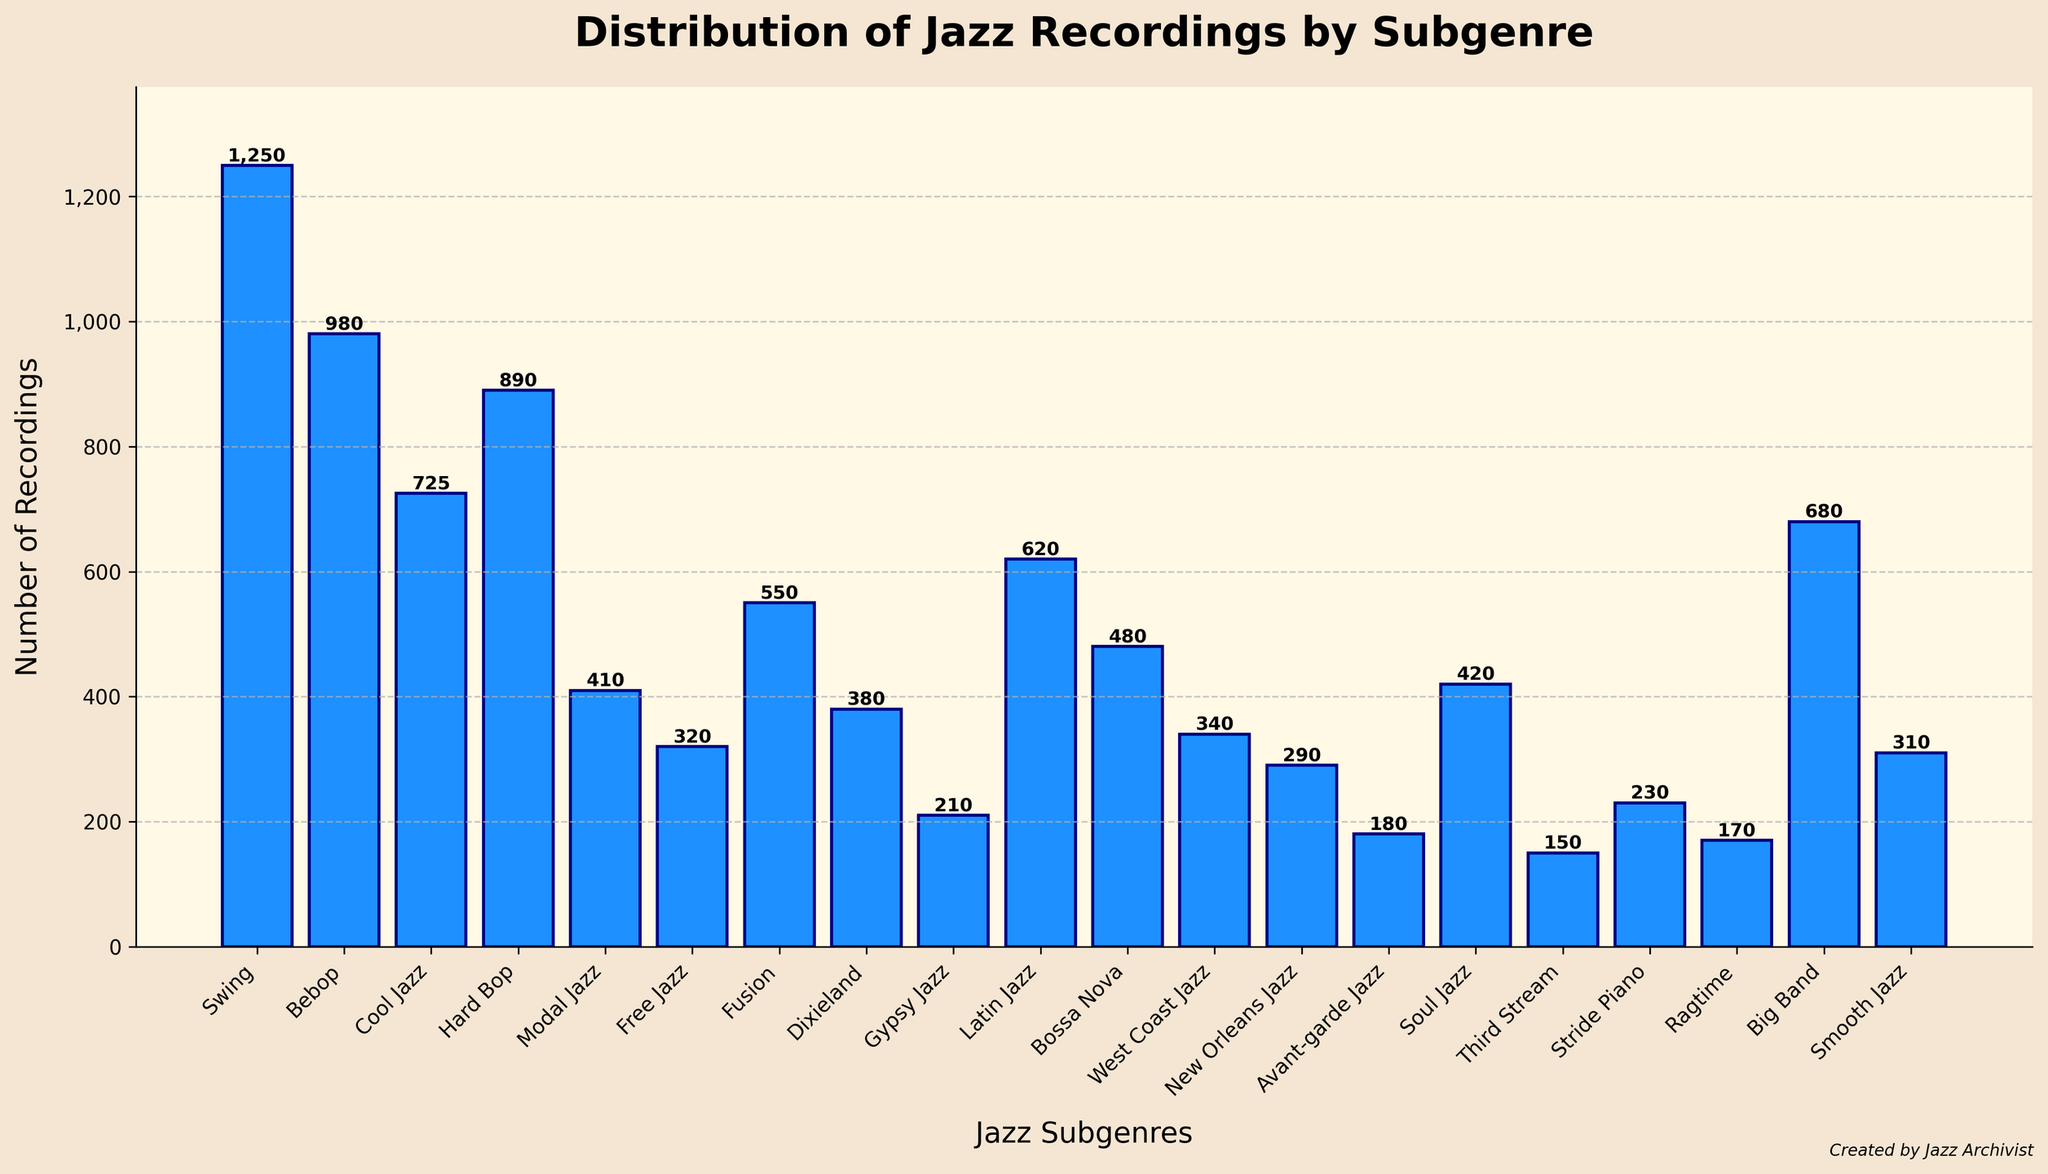What's the most common subgenre of jazz recordings? The figure highlights the frequency of each subgenre by the height of the bars. The tallest bar represents Swing with 1250 recordings, making it the most common subgenre.
Answer: Swing Which subgenre has fewer recordings, Cool Jazz or Bebop? Comparing the bars for Cool Jazz and Bebop shows that Bebop has 980 recordings, which is higher than Cool Jazz's 725 recordings. Thus, Cool Jazz has fewer recordings.
Answer: Cool Jazz What's the combined total of recordings for Free Jazz, Gypsy Jazz, and Ragtime? To find this, add the values of Free Jazz (320), Gypsy Jazz (210), and Ragtime (170). The sum is 320 + 210 + 170 = 700.
Answer: 700 How many more recordings does Swing have compared to Avant-garde Jazz? Subtract the number of recordings for Avant-garde Jazz (180) from Swing (1250). The result is 1250 - 180 = 1070.
Answer: 1070 Which subgenres have fewer than 300 recordings? Bars lower than 300 represent Gypsy Jazz (210), Avant-garde Jazz (180), Third Stream (150), Stride Piano (230), and Ragtime (170).
Answer: Gypsy Jazz, Avant-garde Jazz, Third Stream, Stride Piano, Ragtime How does the number of recordings for Hard Bop compare to Soul Jazz? Hard Bop has 890 recordings while Soul Jazz has 420 recordings. Therefore, Hard Bop has more recordings than Soul Jazz.
Answer: Hard Bop What is the average number of recordings for Latin Jazz, Bossa Nova, and Smooth Jazz? Sum the values (620 + 480 + 310) and then divide by 3. The total is 1410, so the average is 1410 / 3 = 470.
Answer: 470 What's the difference between the number of Big Band and Cool Jazz recordings? Subtract the number of recordings for Cool Jazz (725) from Big Band (680). The result is 680 - 725 = -45. Cool Jazz has 45 more recordings than Big Band.
Answer: 45 fewer Which subgenres have recordings between 300 and 600? The bars within this range include Free Jazz (320), Dixieland (380), Fusion (550), Latin Jazz (620), Bossa Nova (480), West Coast Jazz (340), Soul Jazz (420), and Smooth Jazz (310).
Answer: Free Jazz, Dixieland, Fusion, Bossa Nova, West Coast Jazz, Soul Jazz, Smooth Jazz How many recordings do the top three subgenres have in total? The top three subgenres by number of recordings are Swing (1250), Bebop (980), and Hard Bop (890). Adding these gives a total of 1250 + 980 + 890 = 3120.
Answer: 3120 